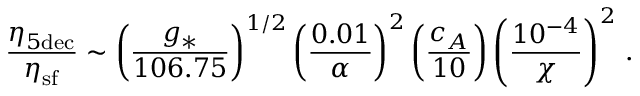<formula> <loc_0><loc_0><loc_500><loc_500>\frac { \eta _ { 5 d e c } } { \eta _ { s f } } \sim \left ( \frac { g _ { \ast } } { 1 0 6 . 7 5 } \right ) ^ { 1 / 2 } \left ( \frac { 0 . 0 1 } { \alpha } \right ) ^ { 2 } \left ( \frac { c _ { A } } { 1 0 } \right ) \left ( \frac { 1 0 ^ { - 4 } } { \chi } \right ) ^ { 2 } \, .</formula> 